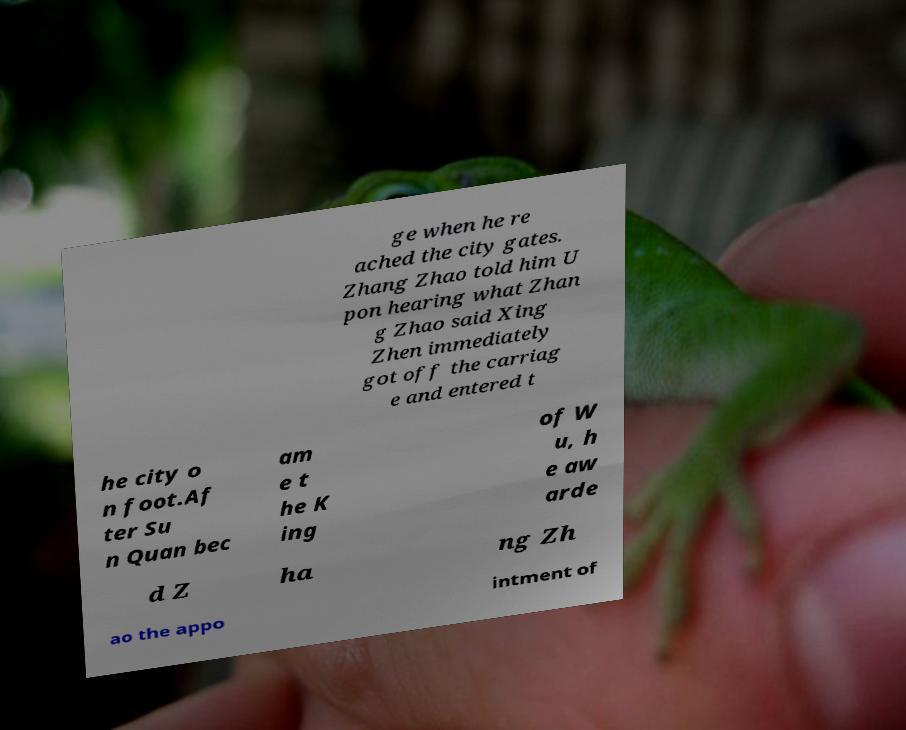Please read and relay the text visible in this image. What does it say? ge when he re ached the city gates. Zhang Zhao told him U pon hearing what Zhan g Zhao said Xing Zhen immediately got off the carriag e and entered t he city o n foot.Af ter Su n Quan bec am e t he K ing of W u, h e aw arde d Z ha ng Zh ao the appo intment of 